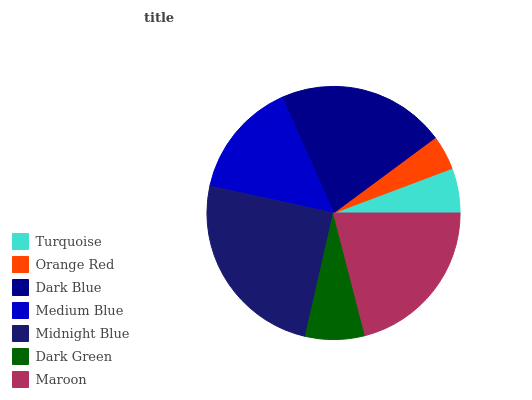Is Orange Red the minimum?
Answer yes or no. Yes. Is Midnight Blue the maximum?
Answer yes or no. Yes. Is Dark Blue the minimum?
Answer yes or no. No. Is Dark Blue the maximum?
Answer yes or no. No. Is Dark Blue greater than Orange Red?
Answer yes or no. Yes. Is Orange Red less than Dark Blue?
Answer yes or no. Yes. Is Orange Red greater than Dark Blue?
Answer yes or no. No. Is Dark Blue less than Orange Red?
Answer yes or no. No. Is Medium Blue the high median?
Answer yes or no. Yes. Is Medium Blue the low median?
Answer yes or no. Yes. Is Dark Green the high median?
Answer yes or no. No. Is Dark Green the low median?
Answer yes or no. No. 